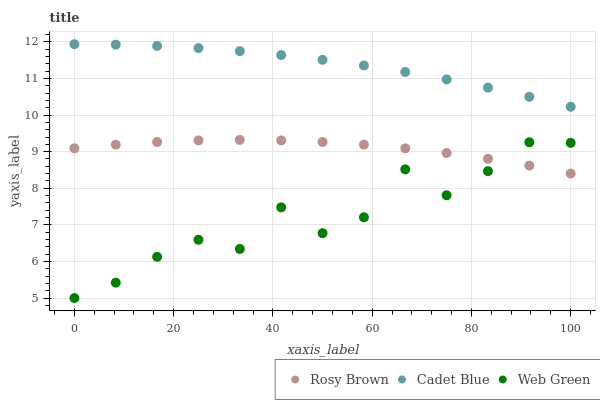Does Web Green have the minimum area under the curve?
Answer yes or no. Yes. Does Cadet Blue have the maximum area under the curve?
Answer yes or no. Yes. Does Rosy Brown have the minimum area under the curve?
Answer yes or no. No. Does Rosy Brown have the maximum area under the curve?
Answer yes or no. No. Is Cadet Blue the smoothest?
Answer yes or no. Yes. Is Web Green the roughest?
Answer yes or no. Yes. Is Rosy Brown the smoothest?
Answer yes or no. No. Is Rosy Brown the roughest?
Answer yes or no. No. Does Web Green have the lowest value?
Answer yes or no. Yes. Does Rosy Brown have the lowest value?
Answer yes or no. No. Does Cadet Blue have the highest value?
Answer yes or no. Yes. Does Rosy Brown have the highest value?
Answer yes or no. No. Is Rosy Brown less than Cadet Blue?
Answer yes or no. Yes. Is Cadet Blue greater than Web Green?
Answer yes or no. Yes. Does Rosy Brown intersect Web Green?
Answer yes or no. Yes. Is Rosy Brown less than Web Green?
Answer yes or no. No. Is Rosy Brown greater than Web Green?
Answer yes or no. No. Does Rosy Brown intersect Cadet Blue?
Answer yes or no. No. 